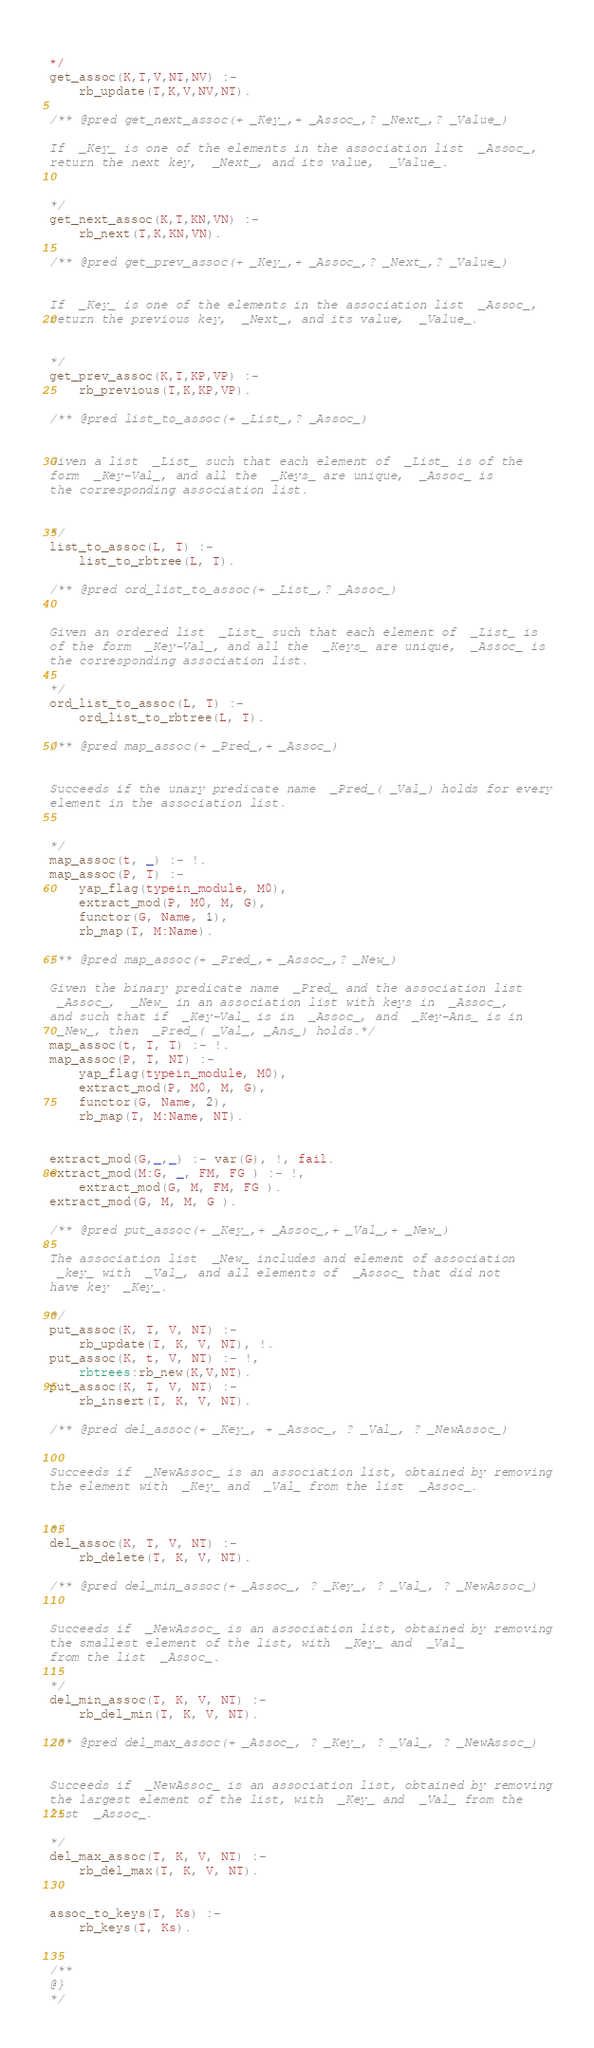<code> <loc_0><loc_0><loc_500><loc_500><_Prolog_> 
*/
get_assoc(K,T,V,NT,NV) :-
	rb_update(T,K,V,NV,NT).

/** @pred get_next_assoc(+ _Key_,+ _Assoc_,? _Next_,? _Value_)

If  _Key_ is one of the elements in the association list  _Assoc_,
return the next key,  _Next_, and its value,  _Value_.

 
*/
get_next_assoc(K,T,KN,VN) :-
	rb_next(T,K,KN,VN).

/** @pred get_prev_assoc(+ _Key_,+ _Assoc_,? _Next_,? _Value_) 


If  _Key_ is one of the elements in the association list  _Assoc_,
return the previous key,  _Next_, and its value,  _Value_.

 
*/
get_prev_assoc(K,T,KP,VP) :-
	rb_previous(T,K,KP,VP).

/** @pred list_to_assoc(+ _List_,? _Assoc_) 


Given a list  _List_ such that each element of  _List_ is of the
form  _Key-Val_, and all the  _Keys_ are unique,  _Assoc_ is
the corresponding association list.

 
*/
list_to_assoc(L, T) :-
	list_to_rbtree(L, T).

/** @pred ord_list_to_assoc(+ _List_,? _Assoc_) 


Given an ordered list  _List_ such that each element of  _List_ is
of the form  _Key-Val_, and all the  _Keys_ are unique,  _Assoc_ is
the corresponding association list.
 
*/
ord_list_to_assoc(L, T) :-
	ord_list_to_rbtree(L, T).

/** @pred map_assoc(+ _Pred_,+ _Assoc_) 


Succeeds if the unary predicate name  _Pred_( _Val_) holds for every
element in the association list.

 
*/
map_assoc(t, _) :- !.
map_assoc(P, T) :-
	yap_flag(typein_module, M0),
	extract_mod(P, M0, M, G),
	functor(G, Name, 1),
	rb_map(T, M:Name).

/** @pred map_assoc(+ _Pred_,+ _Assoc_,? _New_)

Given the binary predicate name  _Pred_ and the association list
 _Assoc_,  _New_ in an association list with keys in  _Assoc_,
and such that if  _Key-Val_ is in  _Assoc_, and  _Key-Ans_ is in
 _New_, then  _Pred_( _Val_, _Ans_) holds.*/
map_assoc(t, T, T) :- !.
map_assoc(P, T, NT) :-
	yap_flag(typein_module, M0),
	extract_mod(P, M0, M, G),
	functor(G, Name, 2),
	rb_map(T, M:Name, NT).


extract_mod(G,_,_) :- var(G), !, fail.
extract_mod(M:G, _, FM, FG ) :- !,
	extract_mod(G, M, FM, FG ).
extract_mod(G, M, M, G ).

/** @pred put_assoc(+ _Key_,+ _Assoc_,+ _Val_,+ _New_) 

The association list  _New_ includes and element of association
 _key_ with  _Val_, and all elements of  _Assoc_ that did not
have key  _Key_.

*/
put_assoc(K, T, V, NT) :-
	rb_update(T, K, V, NT), !.
put_assoc(K, t, V, NT) :- !,
	rbtrees:rb_new(K,V,NT).
put_assoc(K, T, V, NT) :-
	rb_insert(T, K, V, NT).

/** @pred del_assoc(+ _Key_, + _Assoc_, ? _Val_, ? _NewAssoc_) 


Succeeds if  _NewAssoc_ is an association list, obtained by removing
the element with  _Key_ and  _Val_ from the list  _Assoc_.

 
*/
del_assoc(K, T, V, NT) :-
	rb_delete(T, K, V, NT).

/** @pred del_min_assoc(+ _Assoc_, ? _Key_, ? _Val_, ? _NewAssoc_) 


Succeeds if  _NewAssoc_ is an association list, obtained by removing
the smallest element of the list, with  _Key_ and  _Val_
from the list  _Assoc_.
 
*/
del_min_assoc(T, K, V, NT) :-
	rb_del_min(T, K, V, NT).

/** @pred del_max_assoc(+ _Assoc_, ? _Key_, ? _Val_, ? _NewAssoc_) 


Succeeds if  _NewAssoc_ is an association list, obtained by removing
the largest element of the list, with  _Key_ and  _Val_ from the
list  _Assoc_.
 
*/
del_max_assoc(T, K, V, NT) :-
	rb_del_max(T, K, V, NT).


assoc_to_keys(T, Ks) :-
	rb_keys(T, Ks).


/**
@}
*/
</code> 